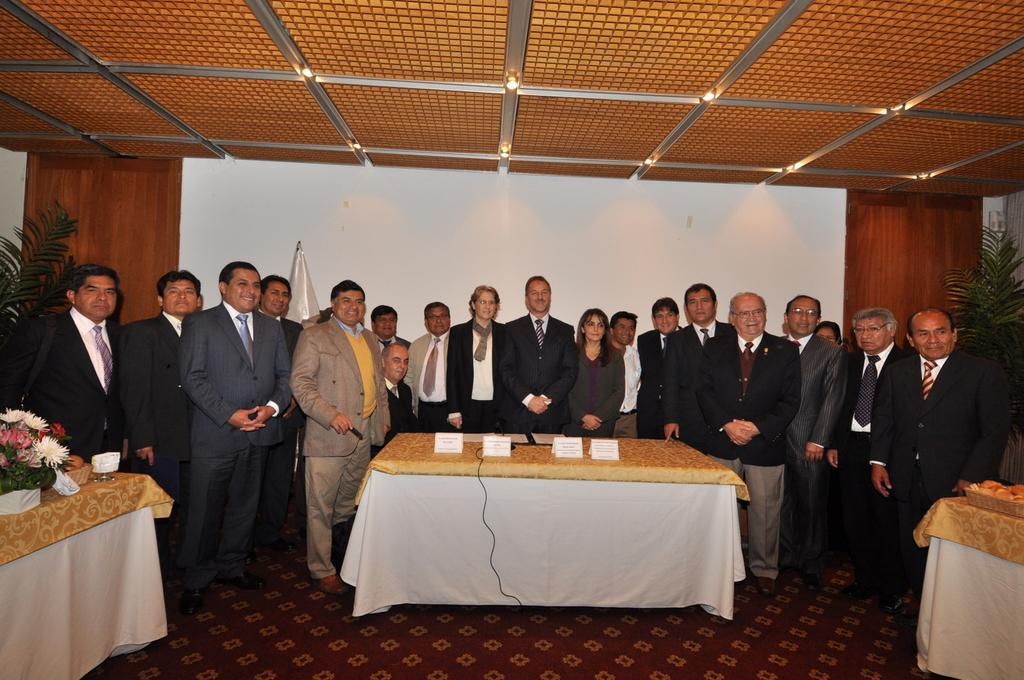Could you give a brief overview of what you see in this image? This image is clicked in a room. There are lights on the top ,there are tables in the middle, left side and right side. In the middle there is a table and cloth is placed on that table. There are name boards on the table. On the left side table there is a flower plant ,on the right side table there is a bowl with some eatables. There are so many people standing in the middle. There are shrubs on the right side and left side. 